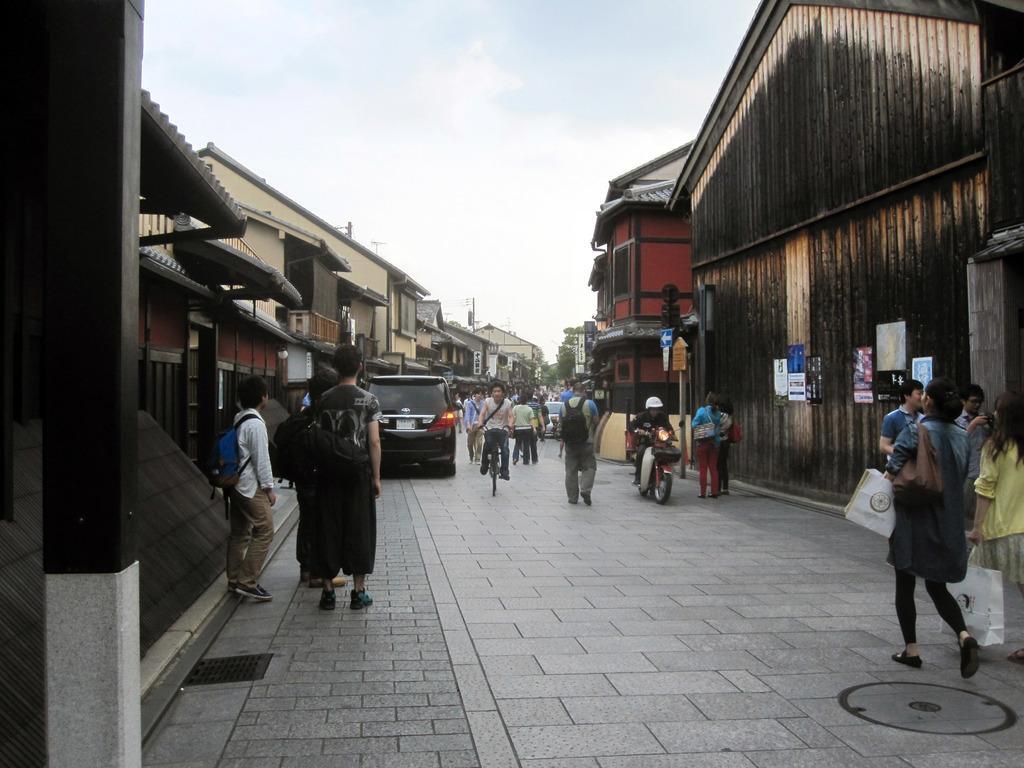In one or two sentences, can you explain what this image depicts? In this image we can see the houses, posters, traffic signal light pole and also the vehicles. We can also see the people, path and there is a person riding the bicycle. We can also see the sky. On the left we can see a pole. 